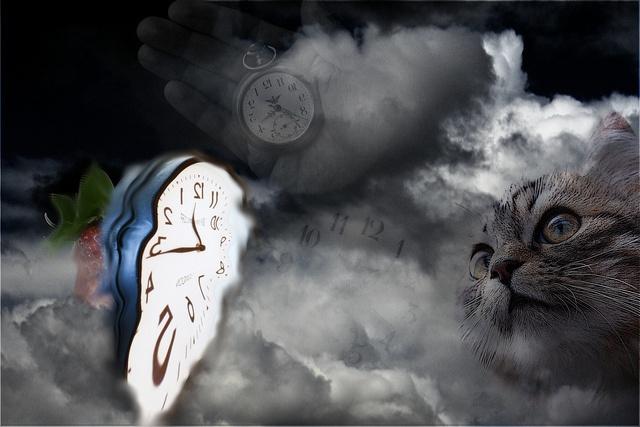Describe the objects in this image and their specific colors. I can see cat in black and gray tones, people in black and gray tones, clock in black, white, darkgray, gray, and maroon tones, and clock in black and gray tones in this image. 